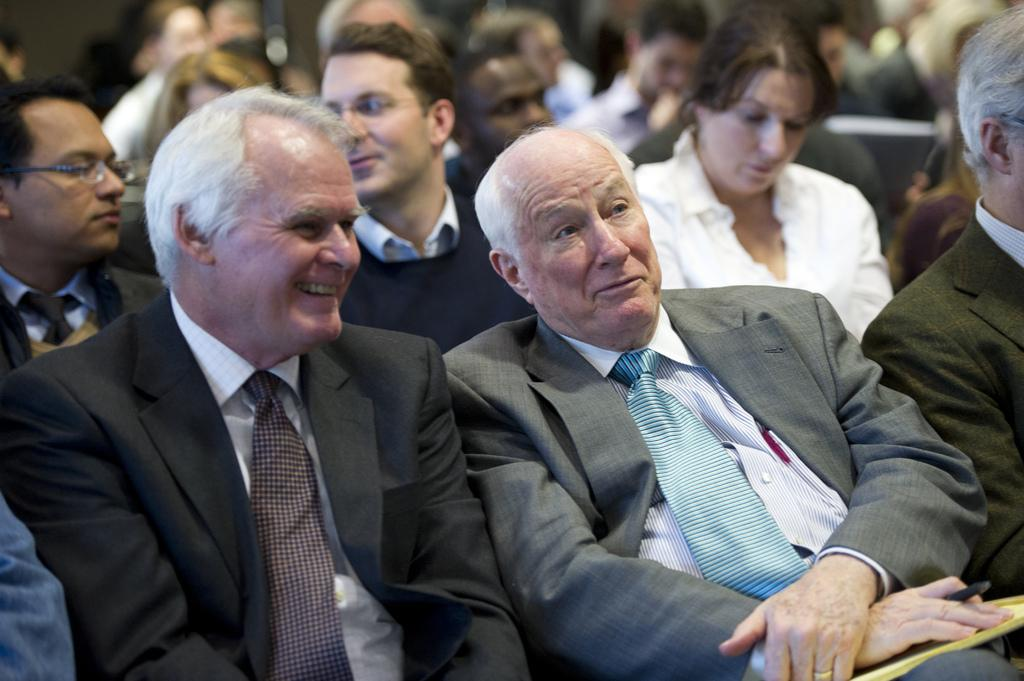How many people are in the group in the image? There is a group of people in the image, but the exact number is not specified. What are some of the people in the group doing? Some people in the group are sitting, and some are smiling. Can you describe the man in the image? The man in the image is holding a pen. What type of mist can be seen surrounding the people in the image? There is no mist present in the image; it features a group of people, some sitting and smiling, with a man holding a pen. 